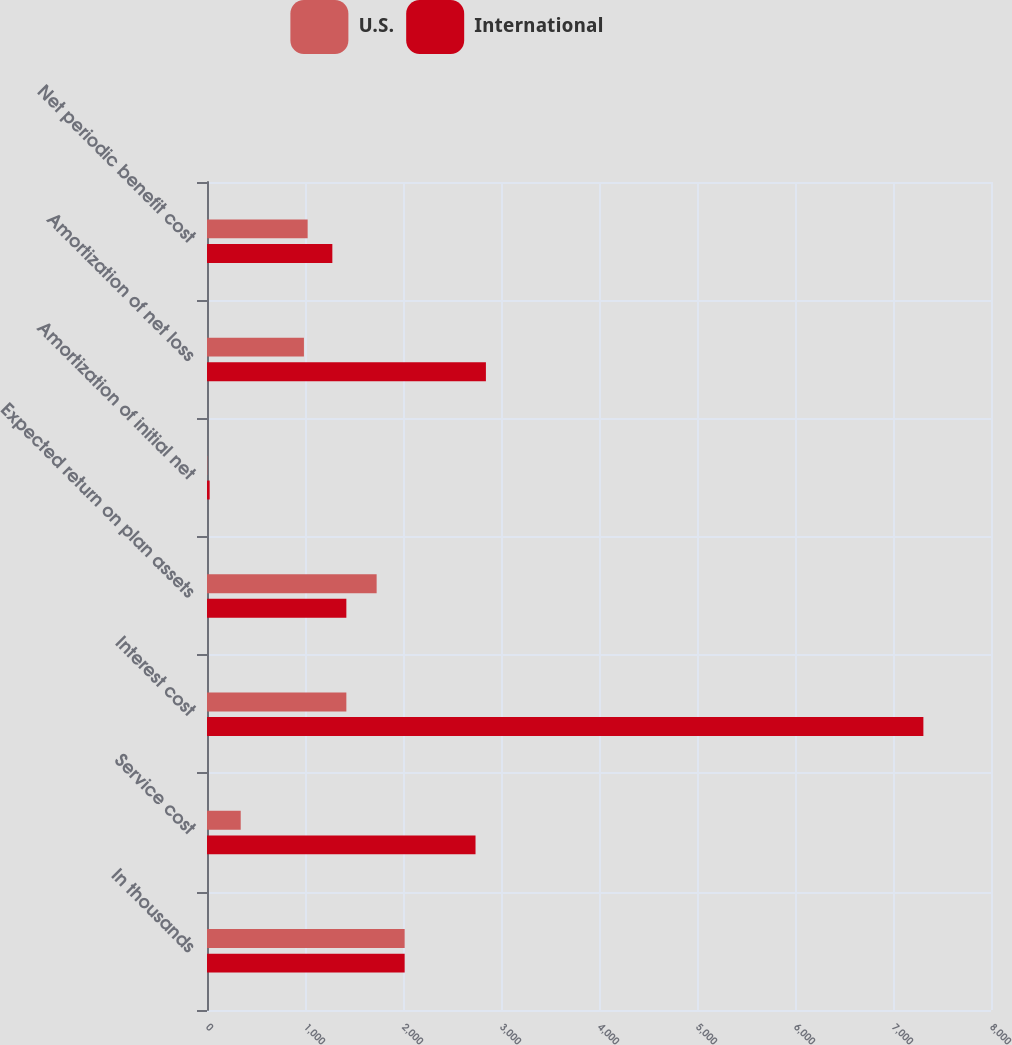<chart> <loc_0><loc_0><loc_500><loc_500><stacked_bar_chart><ecel><fcel>In thousands<fcel>Service cost<fcel>Interest cost<fcel>Expected return on plan assets<fcel>Amortization of initial net<fcel>Amortization of net loss<fcel>Net periodic benefit cost<nl><fcel>U.S.<fcel>2017<fcel>344<fcel>1422<fcel>1731<fcel>3<fcel>989<fcel>1027<nl><fcel>International<fcel>2017<fcel>2740<fcel>7310<fcel>1422<fcel>27<fcel>2846<fcel>1279<nl></chart> 